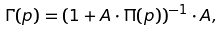<formula> <loc_0><loc_0><loc_500><loc_500>\Gamma ( p ) = ( { 1 } + A \cdot \Pi ( p ) ) ^ { - 1 } \cdot A ,</formula> 